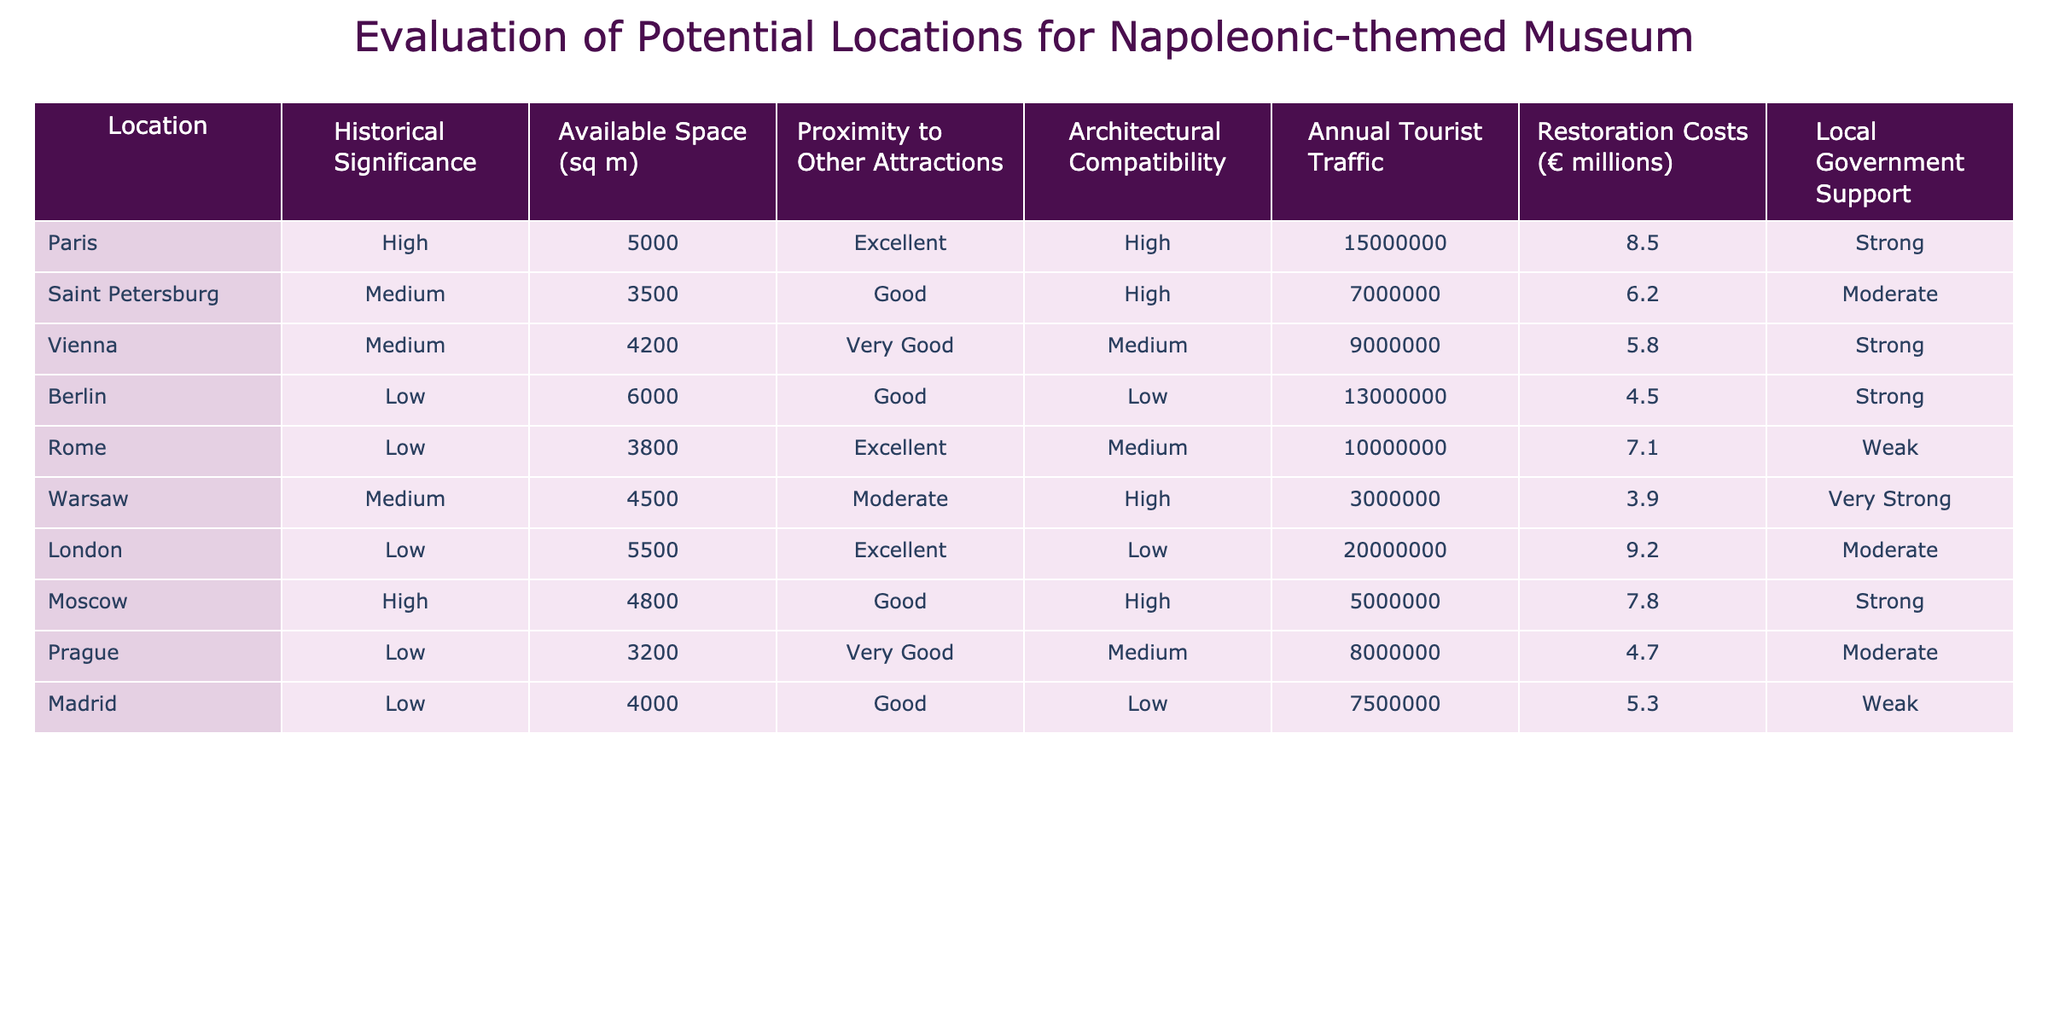What city has the highest annual tourist traffic? By reviewing the 'Annual Tourist Traffic' column, Paris shows the highest number of visitors at 15,000,000.
Answer: Paris Which location has the lowest restoration costs? The 'Restoration Costs (€ millions)' column indicates that Warsaw has the lowest costs at €3.9 million.
Answer: Warsaw Are there any locations with high architectural compatibility and low restoration costs? The locations with high architectural compatibility are Paris, Saint Petersburg, Vienna, Moscow, and Warsaw. Out of these, Warsaw has the lowest restoration costs at €3.9 million. Therefore, yes, Warsaw fits the criteria.
Answer: Yes What is the total available space across all locations? By summing the available space values (5000 + 3500 + 4200 + 6000 + 3800 + 4500 + 5500 + 4800 + 3200 + 4000), the total available space is 39,500 square meters.
Answer: 39500 Which location has good proximity to other attractions but medium historical significance? The table indicates that both Saint Petersburg and Warsaw have 'Good' proximity to other attractions and 'Medium' historical significance.
Answer: Saint Petersburg, Warsaw Is there a location with strong local government support that has low historical significance? According to the table, Berlin and London both have strong government support but low historical significance. Hence, the answer is yes.
Answer: Yes What is the average annual tourist traffic for locations with 'Excellent' proximity to other attractions? The locations with 'Excellent' proximity are Paris, Rome, and London. Their annual tourist traffic values are 15,000,000 (Paris), 10,000,000 (Rome), and 20,000,000 (London). Summing these gives 55,000,000, and dividing by 3 provides an average of 18,333,333.
Answer: 18333333 Which location has high historical significance and low restoration costs? The only location with high historical significance is Paris and Moscow. The restoration costs for Paris are €8.5 million, and for Moscow, it is €7.8 million. Therefore, Moscow qualifies as it has high historical significance and lower costs than Paris.
Answer: Moscow 